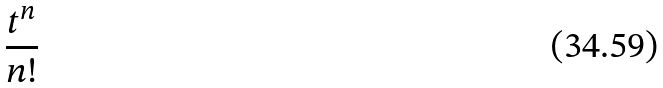<formula> <loc_0><loc_0><loc_500><loc_500>\frac { t ^ { n } } { n ! }</formula> 